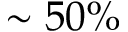Convert formula to latex. <formula><loc_0><loc_0><loc_500><loc_500>\sim 5 0 \%</formula> 